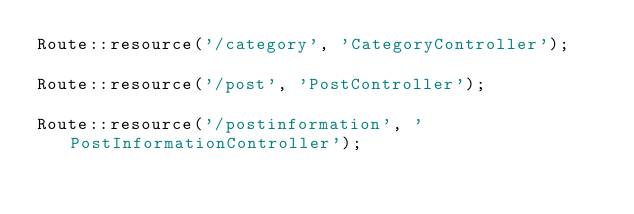<code> <loc_0><loc_0><loc_500><loc_500><_PHP_>Route::resource('/category', 'CategoryController');

Route::resource('/post', 'PostController');

Route::resource('/postinformation', 'PostInformationController');
</code> 